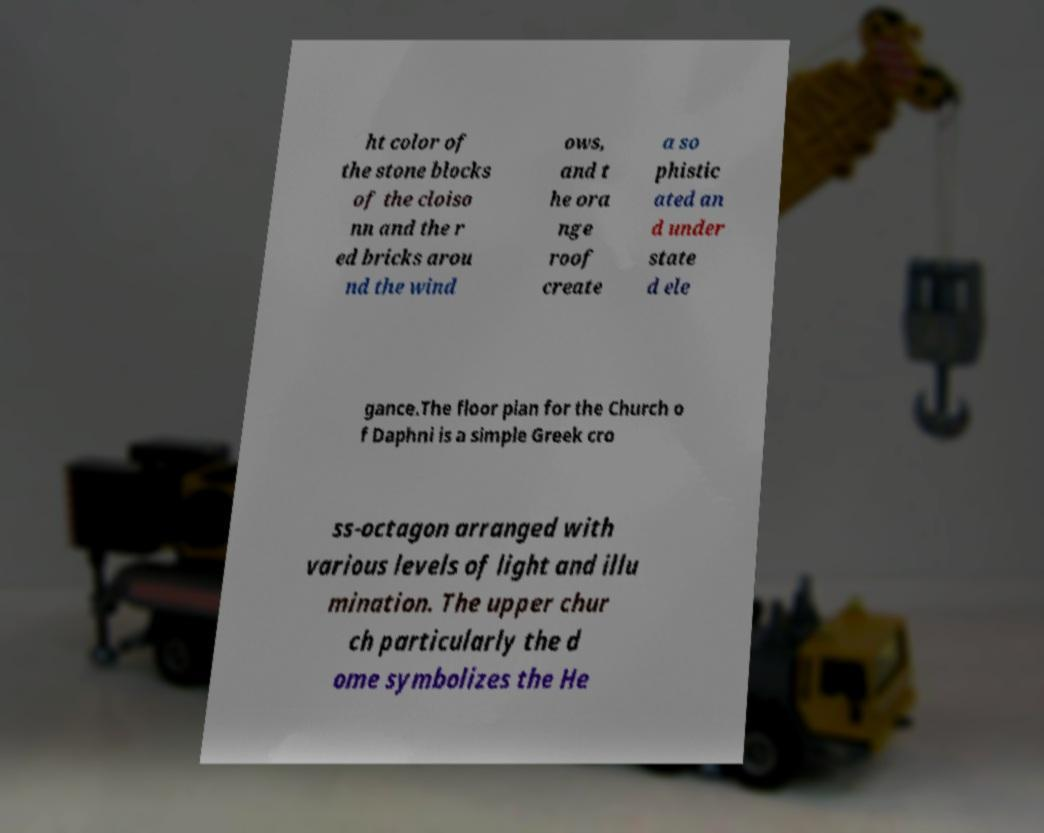Can you read and provide the text displayed in the image?This photo seems to have some interesting text. Can you extract and type it out for me? ht color of the stone blocks of the cloiso nn and the r ed bricks arou nd the wind ows, and t he ora nge roof create a so phistic ated an d under state d ele gance.The floor plan for the Church o f Daphni is a simple Greek cro ss-octagon arranged with various levels of light and illu mination. The upper chur ch particularly the d ome symbolizes the He 